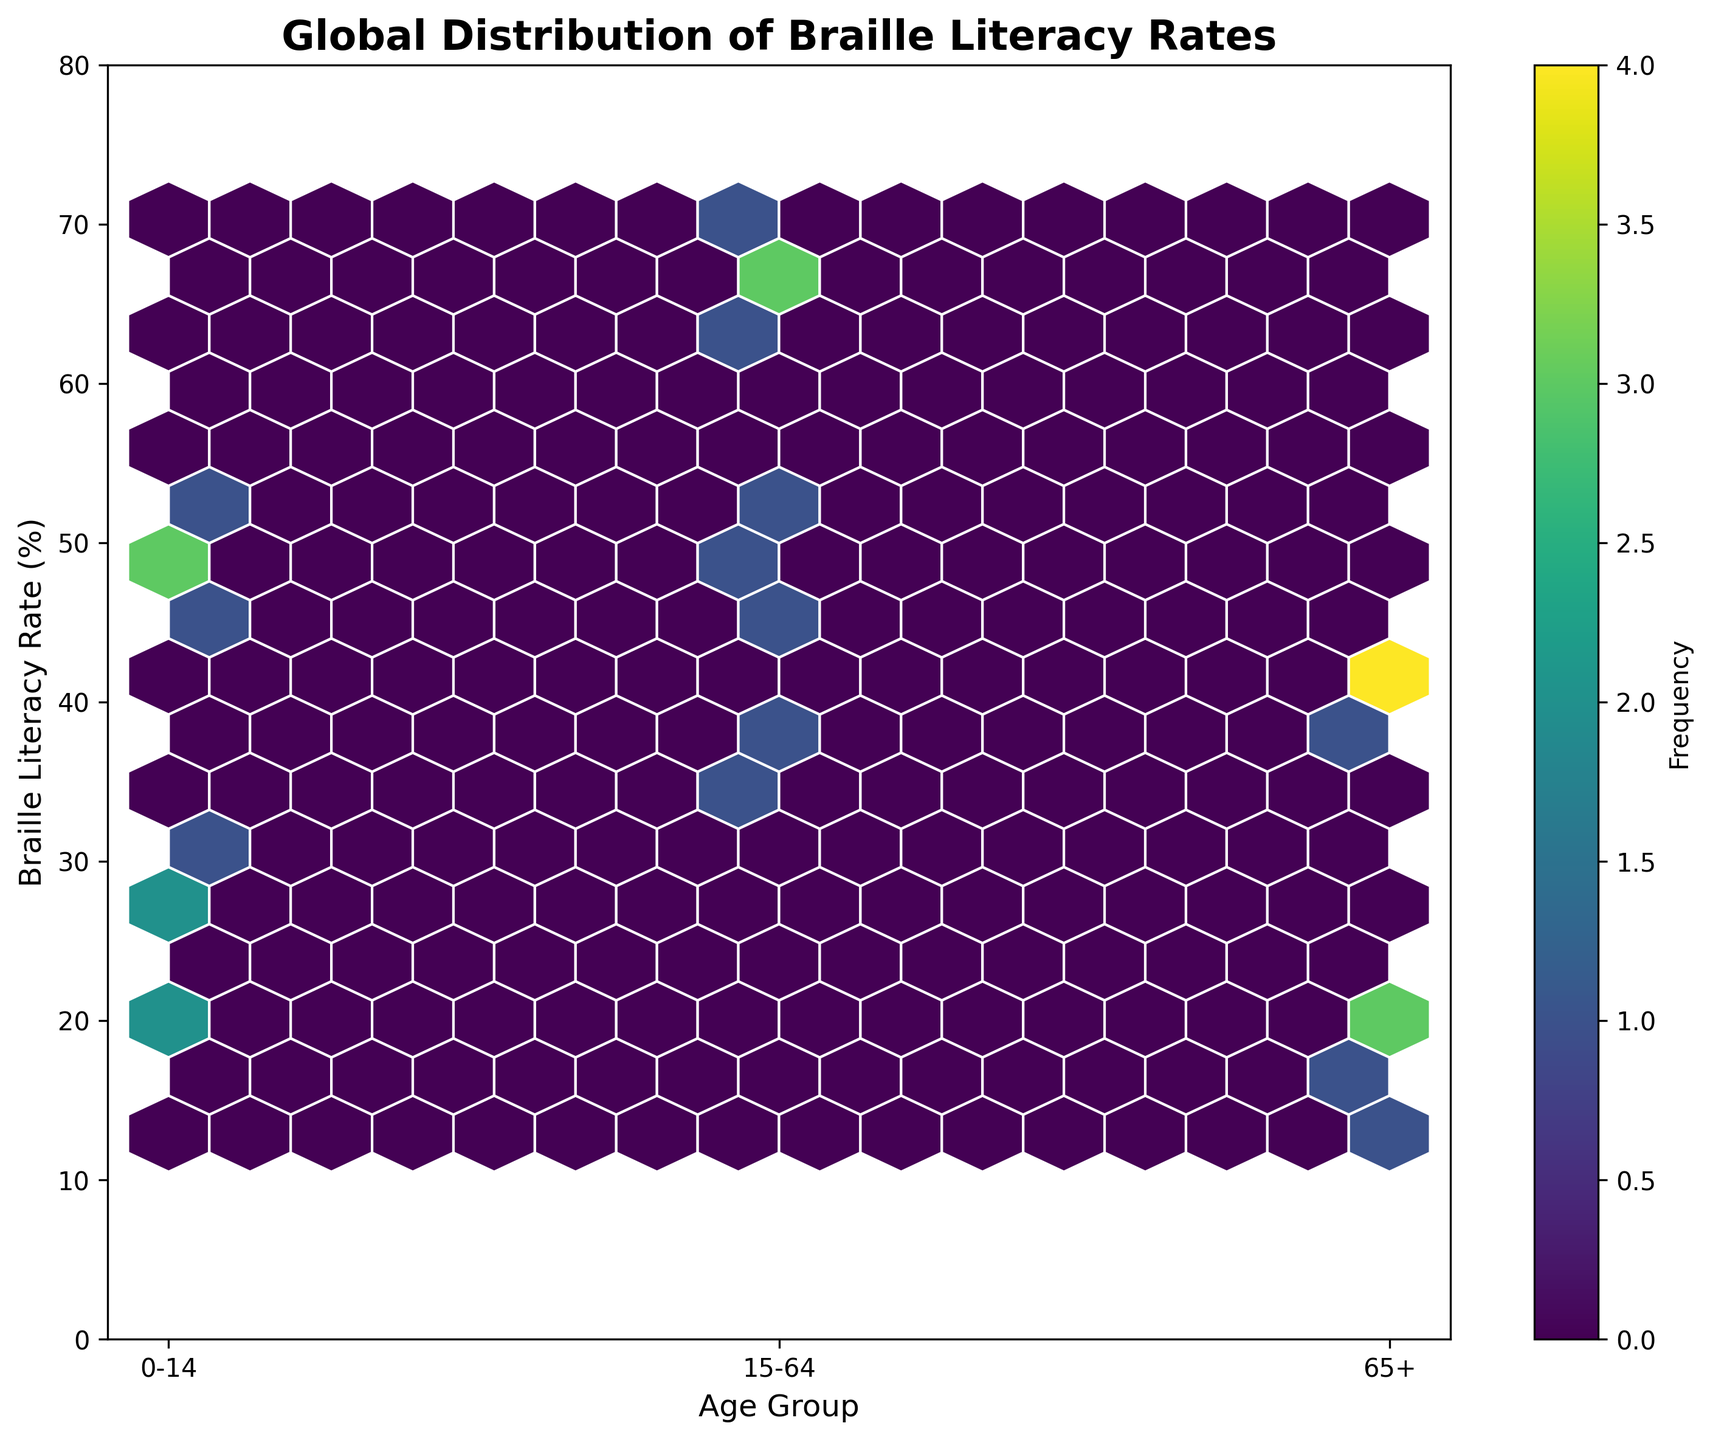What's the title of the figure? The title of the figure is typically displayed at the top of the plot within the figure.
Answer: Global Distribution of Braille Literacy Rates How many age groups are represented in the plot? The x-axis labels represent the age groups. There are three such labels on the x-axis.
Answer: 3 What is the range of Braille Literacy Rates in the figure? The y-axis shows the range of Braille Literacy Rates, which varies from 0 to 80.
Answer: 0 to 80 Which age group has the most data points where the Braille Literacy Rate is above 60%? From the hexbin plot, the color density for rates above 60% is highest around the '15-64' age group.
Answer: 15-64 What is the most frequent range of Braille Literacy Rates for the '0-14' age group? By observing where the color density (frequency) is highest on the y-axis within the '0-14' age group along the x-axis, most data points seem to fall between 20% and 55%.
Answer: 20% to 55% Which country has a higher Braille Literacy Rate in the '65+' age group: the United States or India? Comparing the positions along the y-axis for the '65+' age group, the United States has a rate around 38.5% and India around 12.9%.
Answer: United States What is the average Braille Literacy Rate of the '15-64' age group across all countries? List the rates for '15-64' and calculate the average: (62.8 + 70.3 + 48.9 + 35.2 + 40.1 + 68.5 + 65.9 + 51.6 + 67.2 + 44.7) / 10 = 55.52
Answer: 55.52 Which age group has the lowest maximum Braille Literacy Rate? Compare the highest rates within each age group. The '65+' group has its highest rate at 43.2%, which is lower than the maximum rates for '0-14' and '15-64'.
Answer: 65+ How does the Braille Literacy Rate distribution differ between the '0-14' and '15-64' age groups? The '15-64' age group shows higher Braille Literacy Rates with most data points above 40%, compared to '0-14' where many points are distributed more evenly below and above this threshold.
Answer: 15-64 has higher rates Is there a noticeable trend in Braille Literacy Rates across different age groups globally? Generally, the younger (0-14) and older (65+) age groups have lower literacy rates while the middle age group (15-64) shows higher literacy rates across different countries.
Answer: Yes, middle age group has higher rates 